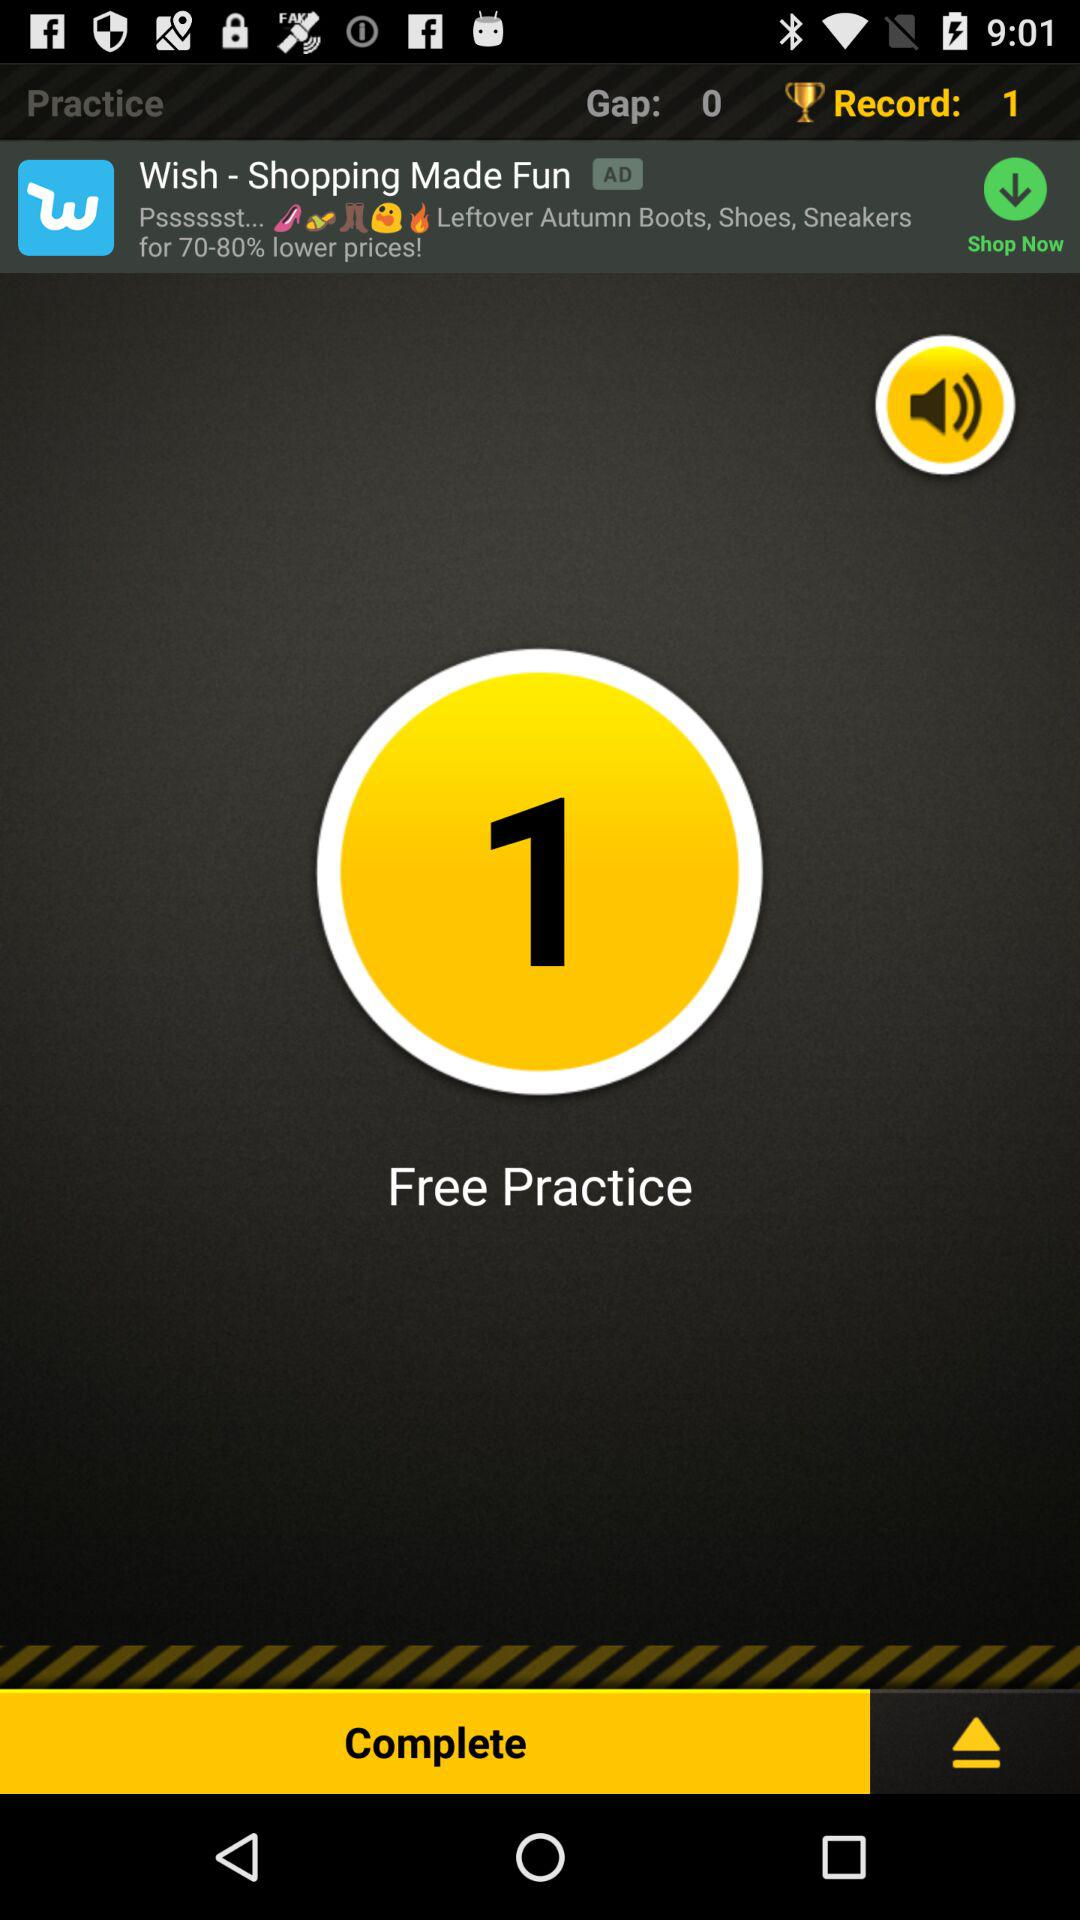What is the count of free practices? The count of free practices is 1. 